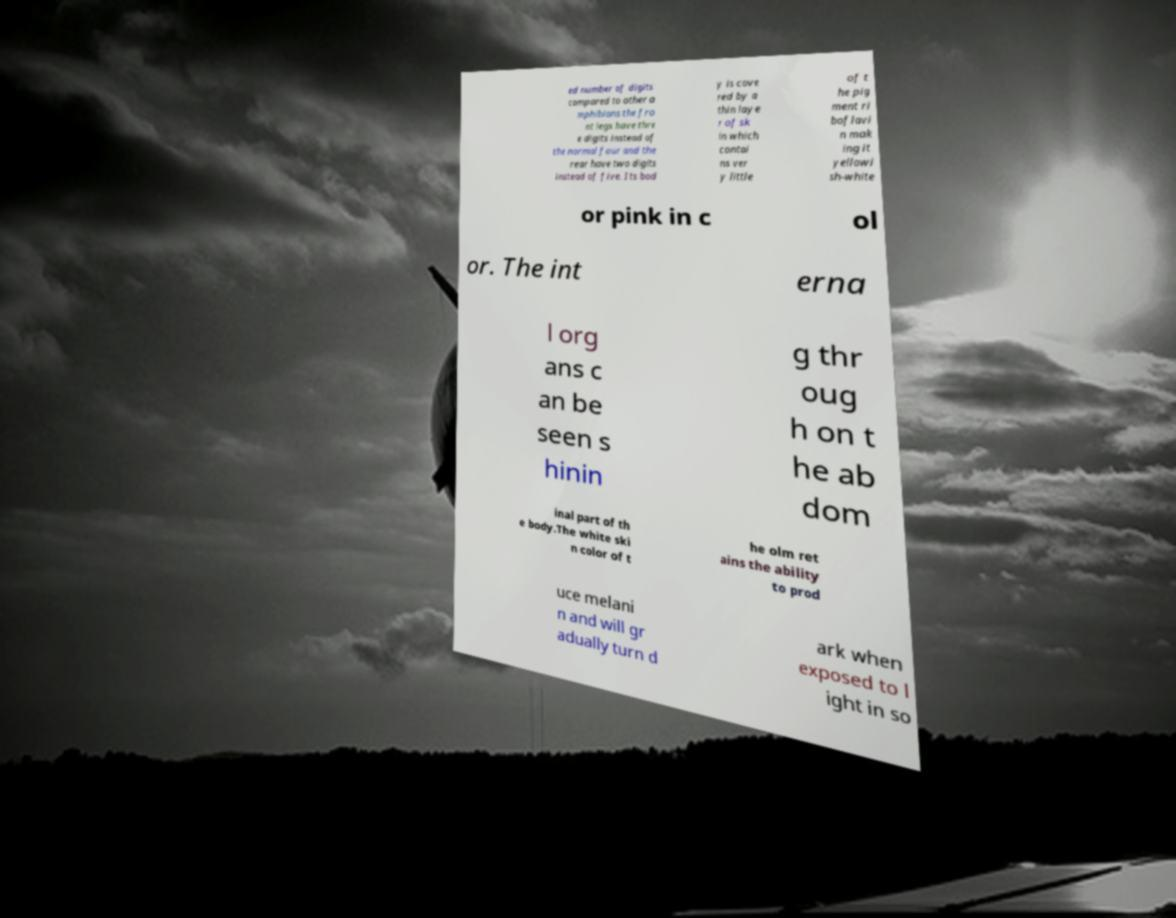What messages or text are displayed in this image? I need them in a readable, typed format. ed number of digits compared to other a mphibians the fro nt legs have thre e digits instead of the normal four and the rear have two digits instead of five. Its bod y is cove red by a thin laye r of sk in which contai ns ver y little of t he pig ment ri boflavi n mak ing it yellowi sh-white or pink in c ol or. The int erna l org ans c an be seen s hinin g thr oug h on t he ab dom inal part of th e body.The white ski n color of t he olm ret ains the ability to prod uce melani n and will gr adually turn d ark when exposed to l ight in so 